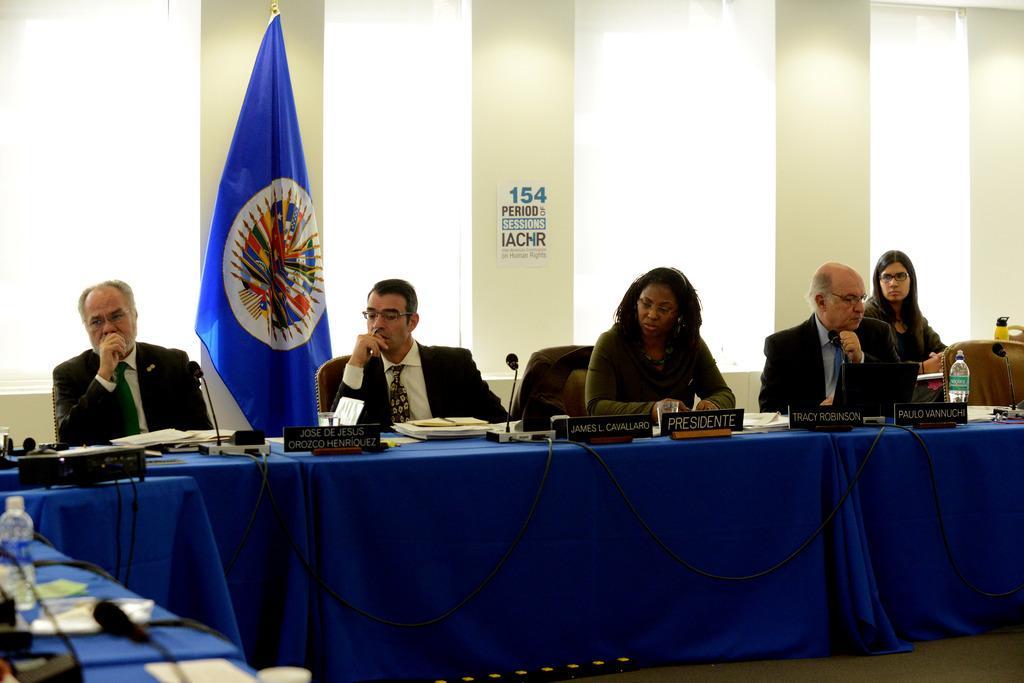Please provide a concise description of this image. In this image there are a few people seated on chairs, in front of them on the table there are papers, some electronic devices name plates and mics and a bottle of water, behind them there is a flag and there is a wall. 